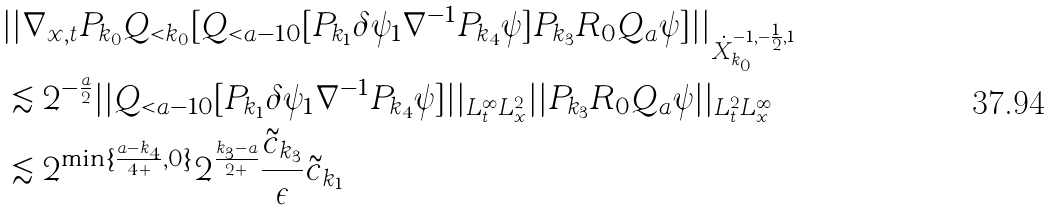<formula> <loc_0><loc_0><loc_500><loc_500>& | | \nabla _ { x , t } P _ { k _ { 0 } } Q _ { < k _ { 0 } } [ Q _ { < a - 1 0 } [ P _ { k _ { 1 } } \delta \psi _ { 1 } \nabla ^ { - 1 } P _ { k _ { 4 } } \psi ] P _ { k _ { 3 } } R _ { 0 } Q _ { a } \psi ] | | _ { \dot { X } _ { k _ { 0 } } ^ { - 1 , - \frac { 1 } { 2 } , 1 } } \\ & \lesssim 2 ^ { - \frac { a } { 2 } } | | Q _ { < a - 1 0 } [ P _ { k _ { 1 } } \delta \psi _ { 1 } \nabla ^ { - 1 } P _ { k _ { 4 } } \psi ] | | _ { L _ { t } ^ { \infty } L _ { x } ^ { 2 } } | | P _ { k _ { 3 } } R _ { 0 } Q _ { a } \psi | | _ { L _ { t } ^ { 2 } L _ { x } ^ { \infty } } \\ & \lesssim 2 ^ { \min \{ \frac { a - k _ { 4 } } { 4 + } , 0 \} } 2 ^ { \frac { k _ { 3 } - a } { 2 + } } \frac { \tilde { c } _ { k _ { 3 } } } { \epsilon } \tilde { c } _ { k _ { 1 } } \\</formula> 